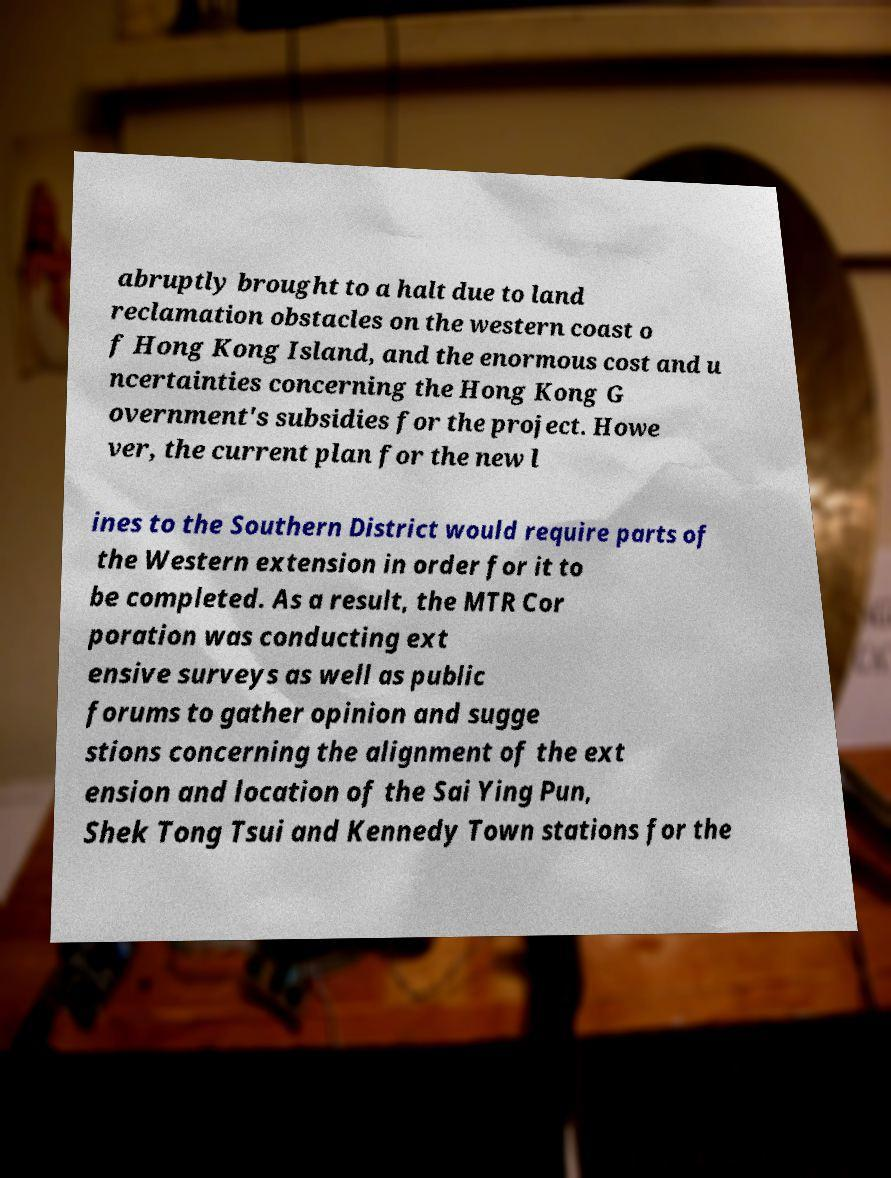Could you extract and type out the text from this image? abruptly brought to a halt due to land reclamation obstacles on the western coast o f Hong Kong Island, and the enormous cost and u ncertainties concerning the Hong Kong G overnment's subsidies for the project. Howe ver, the current plan for the new l ines to the Southern District would require parts of the Western extension in order for it to be completed. As a result, the MTR Cor poration was conducting ext ensive surveys as well as public forums to gather opinion and sugge stions concerning the alignment of the ext ension and location of the Sai Ying Pun, Shek Tong Tsui and Kennedy Town stations for the 